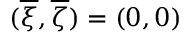<formula> <loc_0><loc_0><loc_500><loc_500>( { \overline { \xi } } , { \overline { \zeta } } ) = ( 0 , 0 )</formula> 